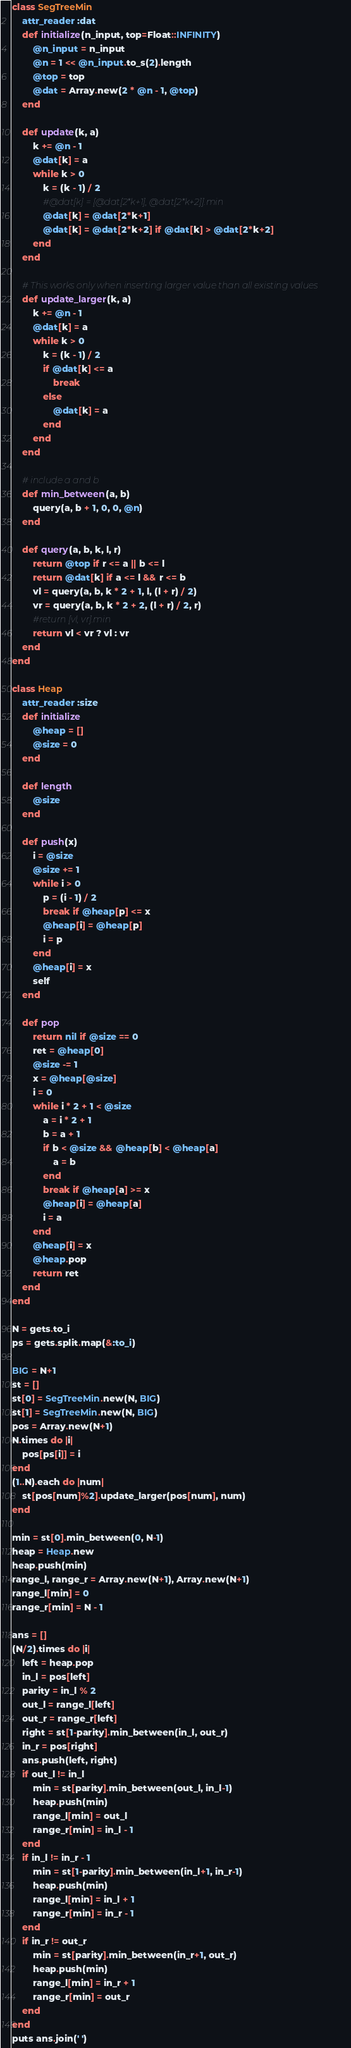Convert code to text. <code><loc_0><loc_0><loc_500><loc_500><_Ruby_>class SegTreeMin
    attr_reader :dat
    def initialize(n_input, top=Float::INFINITY)
        @n_input = n_input
        @n = 1 << @n_input.to_s(2).length
        @top = top
        @dat = Array.new(2 * @n - 1, @top)
    end

    def update(k, a)
        k += @n - 1
        @dat[k] = a
        while k > 0
            k = (k - 1) / 2
            #@dat[k] = [@dat[2*k+1], @dat[2*k+2]].min
            @dat[k] = @dat[2*k+1]
            @dat[k] = @dat[2*k+2] if @dat[k] > @dat[2*k+2]
        end
    end

    # This works only when inserting larger value than all existing values
    def update_larger(k, a)
        k += @n - 1
        @dat[k] = a
        while k > 0
            k = (k - 1) / 2
            if @dat[k] <= a
                break
            else
                @dat[k] = a
            end
        end
    end

    # include a and b
    def min_between(a, b)
        query(a, b + 1, 0, 0, @n)
    end

    def query(a, b, k, l, r)
        return @top if r <= a || b <= l
        return @dat[k] if a <= l && r <= b
        vl = query(a, b, k * 2 + 1, l, (l + r) / 2)
        vr = query(a, b, k * 2 + 2, (l + r) / 2, r)
        #return [vl, vr].min
        return vl < vr ? vl : vr
    end
end

class Heap
    attr_reader :size
    def initialize
        @heap = []
        @size = 0
    end

    def length
        @size
    end

    def push(x)
        i = @size
        @size += 1
        while i > 0
            p = (i - 1) / 2
            break if @heap[p] <= x
            @heap[i] = @heap[p]
            i = p
        end
        @heap[i] = x
        self
    end

    def pop
        return nil if @size == 0
        ret = @heap[0]
        @size -= 1
        x = @heap[@size]
        i = 0
        while i * 2 + 1 < @size
            a = i * 2 + 1
            b = a + 1
            if b < @size && @heap[b] < @heap[a]
                a = b
            end
            break if @heap[a] >= x
            @heap[i] = @heap[a]
            i = a
        end
        @heap[i] = x
        @heap.pop
        return ret
    end
end

N = gets.to_i
ps = gets.split.map(&:to_i)

BIG = N+1
st = []
st[0] = SegTreeMin.new(N, BIG)
st[1] = SegTreeMin.new(N, BIG)
pos = Array.new(N+1)
N.times do |i|
    pos[ps[i]] = i
end
(1..N).each do |num|
    st[pos[num]%2].update_larger(pos[num], num)
end

min = st[0].min_between(0, N-1)
heap = Heap.new
heap.push(min)
range_l, range_r = Array.new(N+1), Array.new(N+1)
range_l[min] = 0
range_r[min] = N - 1

ans = []
(N/2).times do |i|
    left = heap.pop
    in_l = pos[left]
    parity = in_l % 2
    out_l = range_l[left]
    out_r = range_r[left]
    right = st[1-parity].min_between(in_l, out_r)
    in_r = pos[right]
    ans.push(left, right)
    if out_l != in_l
        min = st[parity].min_between(out_l, in_l-1)
        heap.push(min)
        range_l[min] = out_l
        range_r[min] = in_l - 1
    end
    if in_l != in_r - 1
        min = st[1-parity].min_between(in_l+1, in_r-1)
        heap.push(min)
        range_l[min] = in_l + 1
        range_r[min] = in_r - 1
    end
    if in_r != out_r
        min = st[parity].min_between(in_r+1, out_r)
        heap.push(min)
        range_l[min] = in_r + 1
        range_r[min] = out_r
    end
end
puts ans.join(' ')</code> 